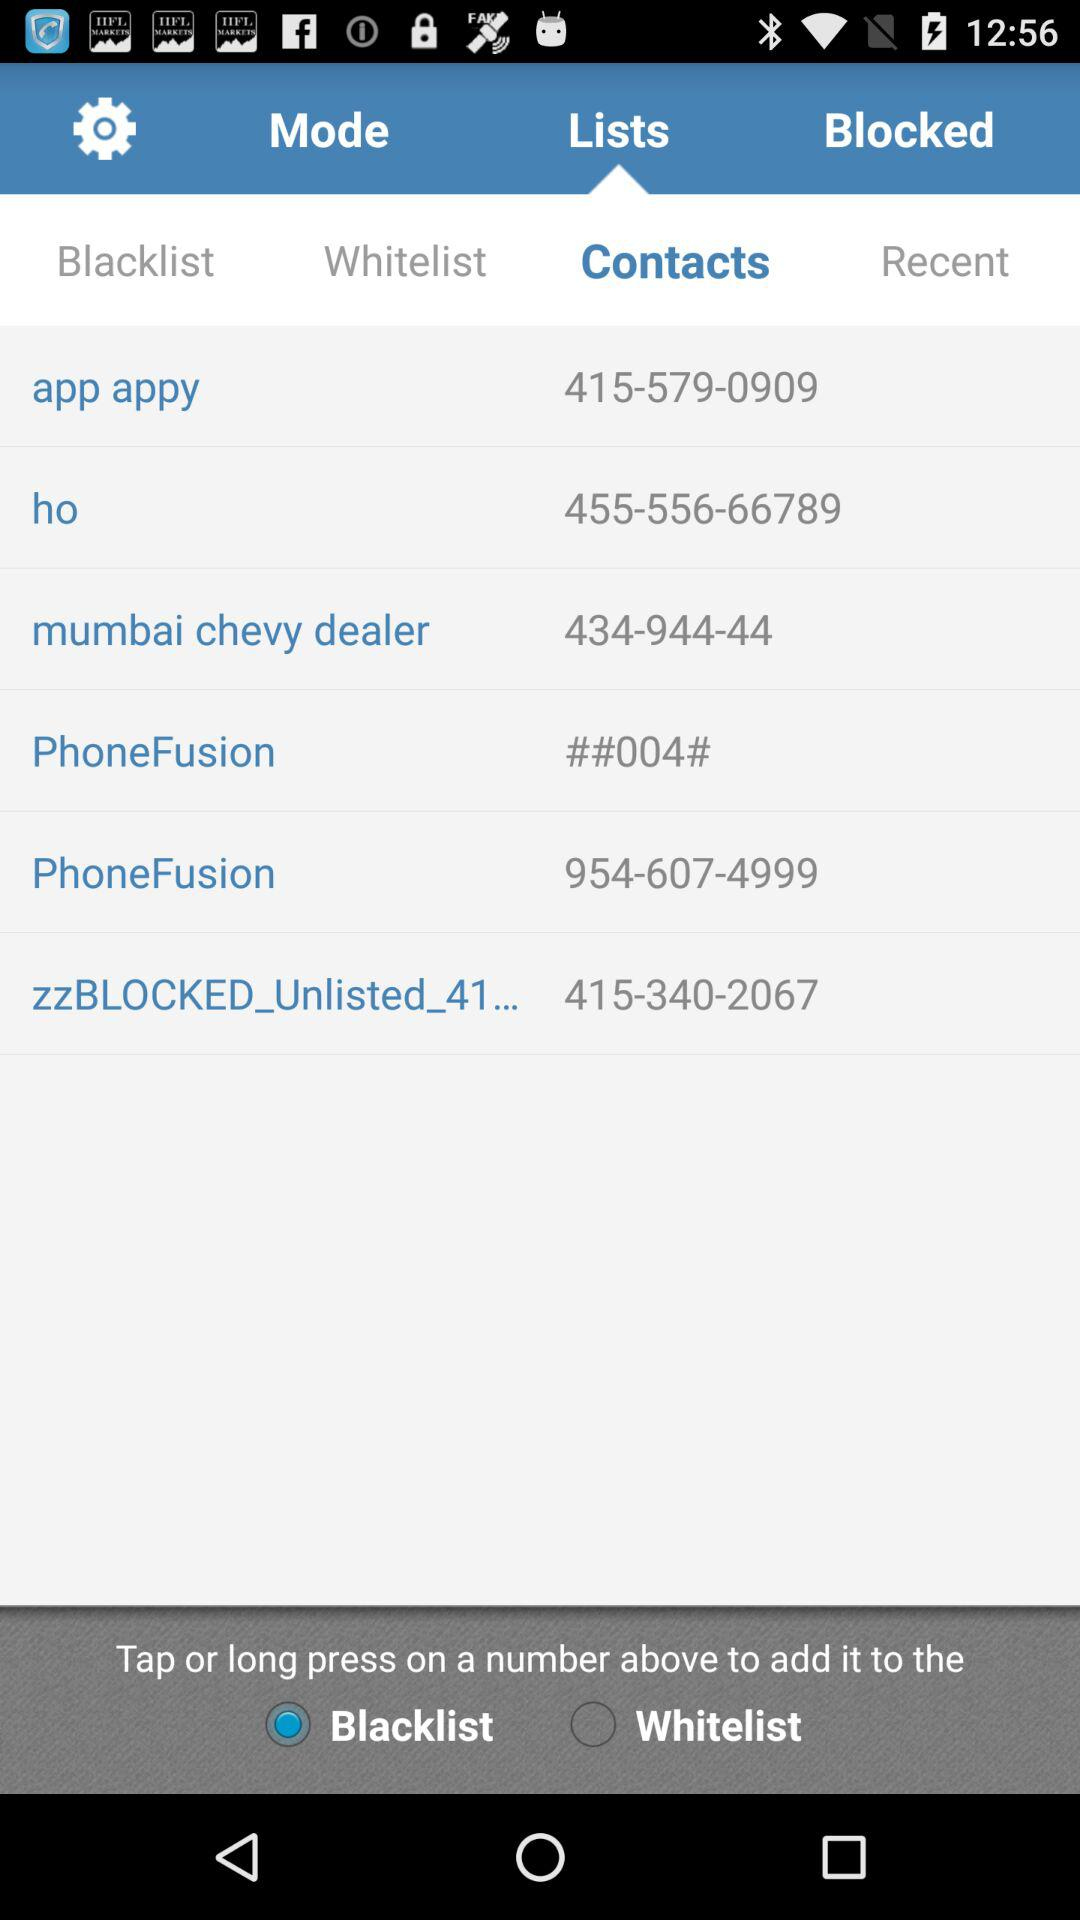What is the status of "Blacklist"? The status is "on". 